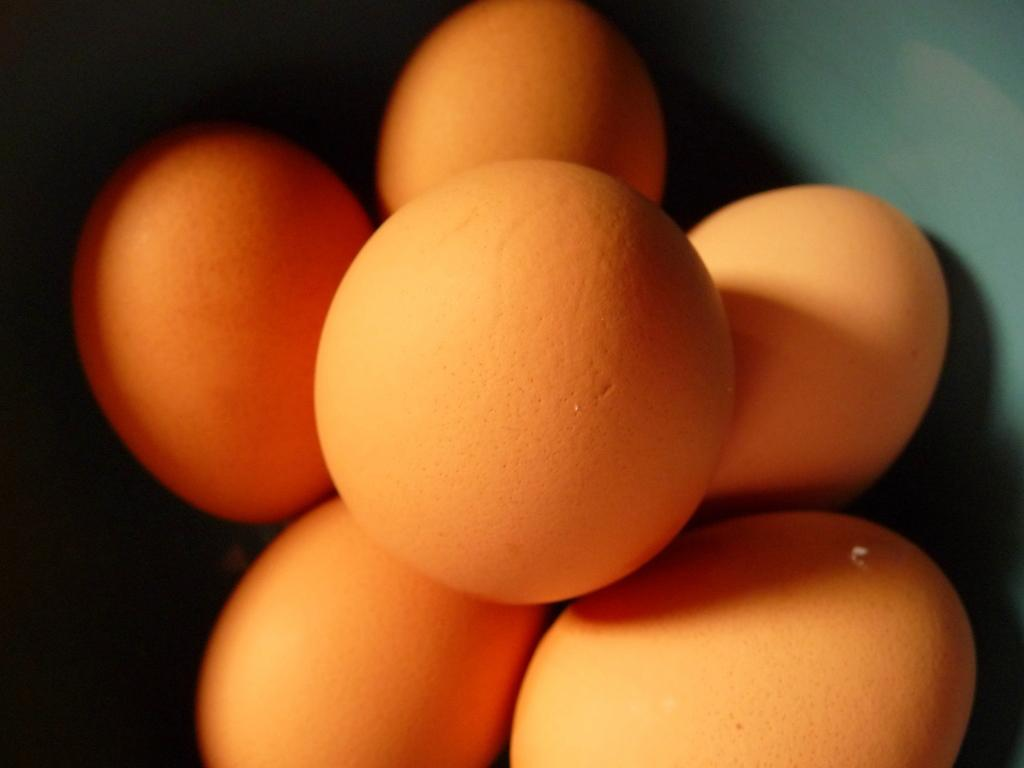What is present in the image? There is a bowl in the image. What is inside the bowl? There are eggs in the bowl. What color is the paint on the eggs in the image? There is no paint on the eggs in the image, as they are plain and unadorned. 